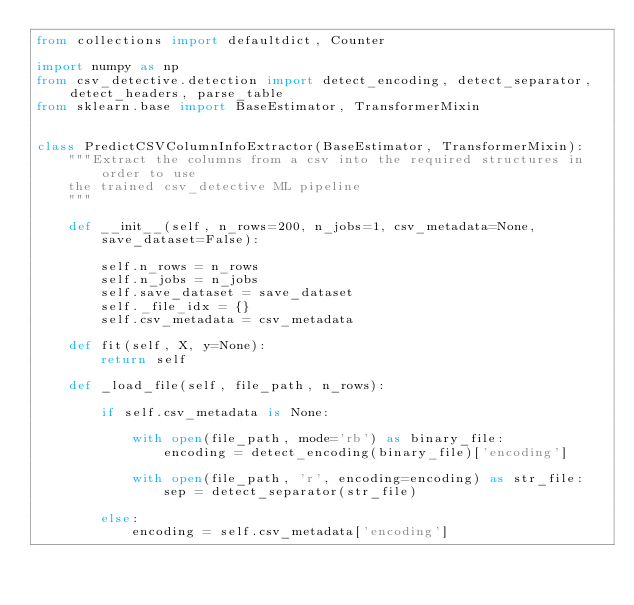<code> <loc_0><loc_0><loc_500><loc_500><_Python_>from collections import defaultdict, Counter

import numpy as np
from csv_detective.detection import detect_encoding, detect_separator, detect_headers, parse_table
from sklearn.base import BaseEstimator, TransformerMixin


class PredictCSVColumnInfoExtractor(BaseEstimator, TransformerMixin):
    """Extract the columns from a csv into the required structures in order to use
    the trained csv_detective ML pipeline
    """

    def __init__(self, n_rows=200, n_jobs=1, csv_metadata=None, save_dataset=False):

        self.n_rows = n_rows
        self.n_jobs = n_jobs
        self.save_dataset = save_dataset
        self._file_idx = {}
        self.csv_metadata = csv_metadata

    def fit(self, X, y=None):
        return self

    def _load_file(self, file_path, n_rows):

        if self.csv_metadata is None:

            with open(file_path, mode='rb') as binary_file:
                encoding = detect_encoding(binary_file)['encoding']

            with open(file_path, 'r', encoding=encoding) as str_file:
                sep = detect_separator(str_file)

        else:
            encoding = self.csv_metadata['encoding']</code> 